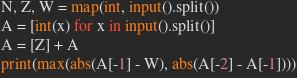<code> <loc_0><loc_0><loc_500><loc_500><_Python_>N, Z, W = map(int, input().split())
A = [int(x) for x in input().split()]
A = [Z] + A
print(max(abs(A[-1] - W), abs(A[-2] - A[-1])))</code> 